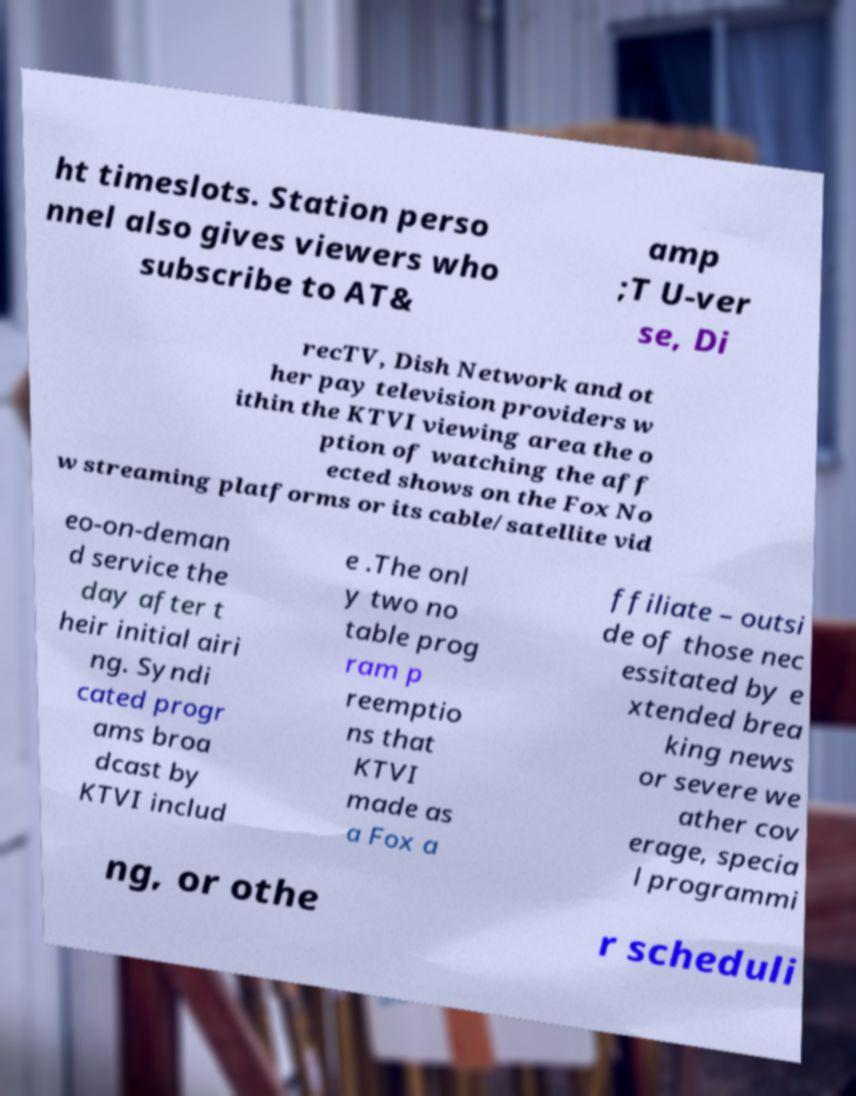What messages or text are displayed in this image? I need them in a readable, typed format. ht timeslots. Station perso nnel also gives viewers who subscribe to AT& amp ;T U-ver se, Di recTV, Dish Network and ot her pay television providers w ithin the KTVI viewing area the o ption of watching the aff ected shows on the Fox No w streaming platforms or its cable/satellite vid eo-on-deman d service the day after t heir initial airi ng. Syndi cated progr ams broa dcast by KTVI includ e .The onl y two no table prog ram p reemptio ns that KTVI made as a Fox a ffiliate – outsi de of those nec essitated by e xtended brea king news or severe we ather cov erage, specia l programmi ng, or othe r scheduli 